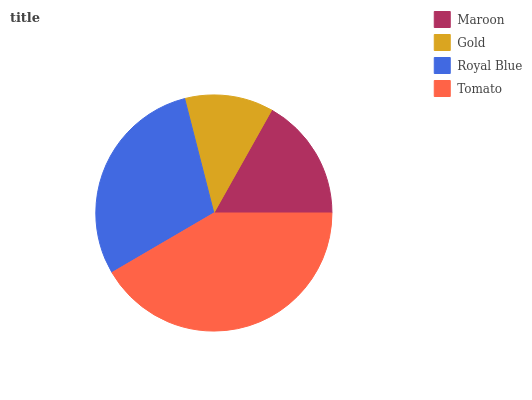Is Gold the minimum?
Answer yes or no. Yes. Is Tomato the maximum?
Answer yes or no. Yes. Is Royal Blue the minimum?
Answer yes or no. No. Is Royal Blue the maximum?
Answer yes or no. No. Is Royal Blue greater than Gold?
Answer yes or no. Yes. Is Gold less than Royal Blue?
Answer yes or no. Yes. Is Gold greater than Royal Blue?
Answer yes or no. No. Is Royal Blue less than Gold?
Answer yes or no. No. Is Royal Blue the high median?
Answer yes or no. Yes. Is Maroon the low median?
Answer yes or no. Yes. Is Tomato the high median?
Answer yes or no. No. Is Tomato the low median?
Answer yes or no. No. 